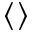<formula> <loc_0><loc_0><loc_500><loc_500>\langle \rangle</formula> 